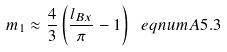<formula> <loc_0><loc_0><loc_500><loc_500>m _ { 1 } \approx \frac { 4 } { 3 } \left ( \frac { l _ { B x } } { \pi } - 1 \right ) \ e q n u m { A 5 . 3 }</formula> 